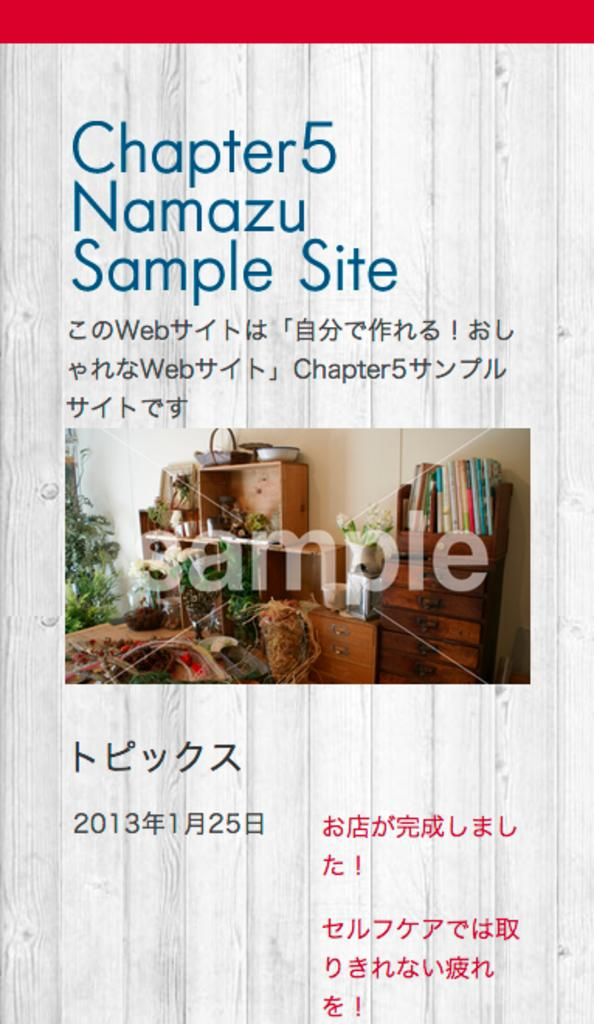<image>
Write a terse but informative summary of the picture. A book called Namazu Sample site shows samples of images. 